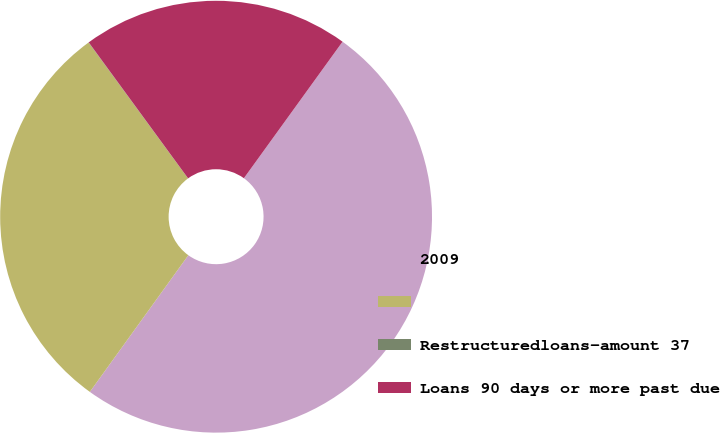<chart> <loc_0><loc_0><loc_500><loc_500><pie_chart><fcel>2009<fcel>Unnamed: 1<fcel>Restructuredloans-amount 37<fcel>Loans 90 days or more past due<nl><fcel>49.98%<fcel>30.0%<fcel>0.02%<fcel>20.0%<nl></chart> 